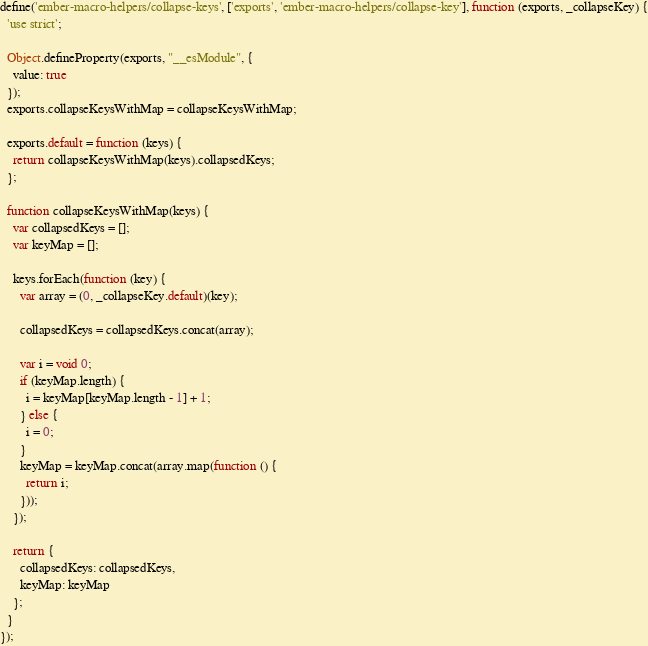Convert code to text. <code><loc_0><loc_0><loc_500><loc_500><_JavaScript_>define('ember-macro-helpers/collapse-keys', ['exports', 'ember-macro-helpers/collapse-key'], function (exports, _collapseKey) {
  'use strict';

  Object.defineProperty(exports, "__esModule", {
    value: true
  });
  exports.collapseKeysWithMap = collapseKeysWithMap;

  exports.default = function (keys) {
    return collapseKeysWithMap(keys).collapsedKeys;
  };

  function collapseKeysWithMap(keys) {
    var collapsedKeys = [];
    var keyMap = [];

    keys.forEach(function (key) {
      var array = (0, _collapseKey.default)(key);

      collapsedKeys = collapsedKeys.concat(array);

      var i = void 0;
      if (keyMap.length) {
        i = keyMap[keyMap.length - 1] + 1;
      } else {
        i = 0;
      }
      keyMap = keyMap.concat(array.map(function () {
        return i;
      }));
    });

    return {
      collapsedKeys: collapsedKeys,
      keyMap: keyMap
    };
  }
});</code> 